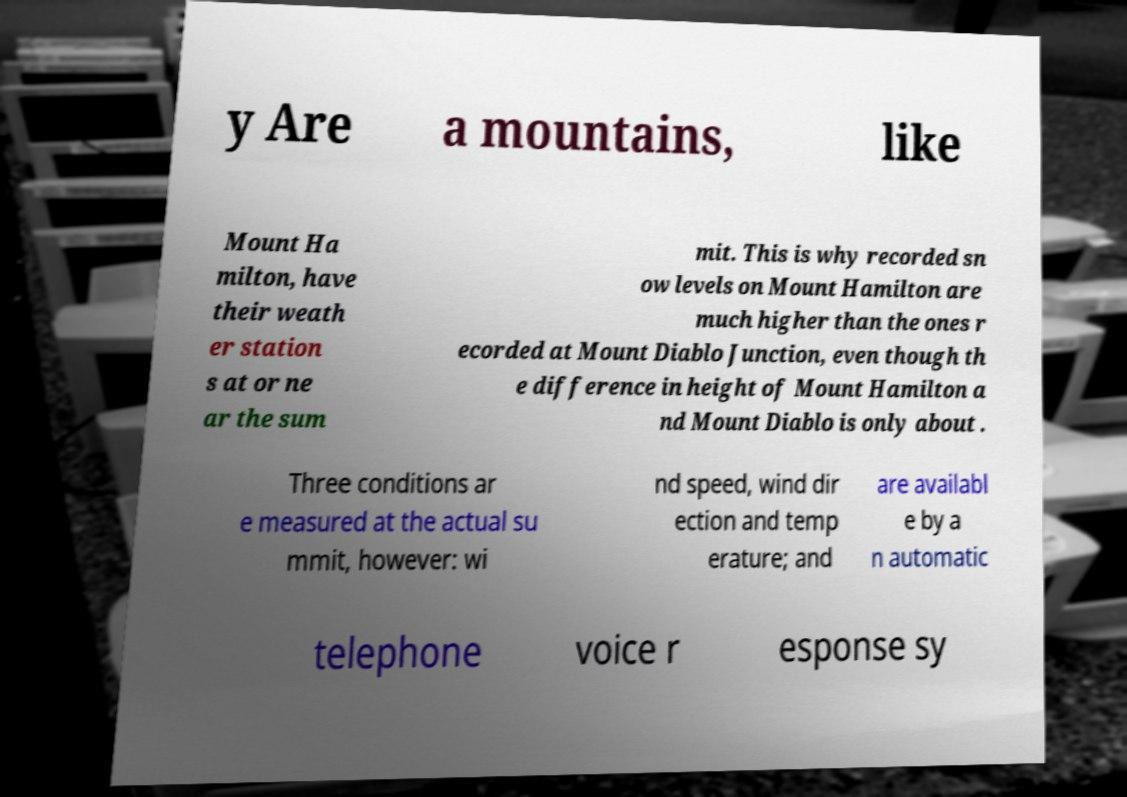Can you read and provide the text displayed in the image?This photo seems to have some interesting text. Can you extract and type it out for me? y Are a mountains, like Mount Ha milton, have their weath er station s at or ne ar the sum mit. This is why recorded sn ow levels on Mount Hamilton are much higher than the ones r ecorded at Mount Diablo Junction, even though th e difference in height of Mount Hamilton a nd Mount Diablo is only about . Three conditions ar e measured at the actual su mmit, however: wi nd speed, wind dir ection and temp erature; and are availabl e by a n automatic telephone voice r esponse sy 